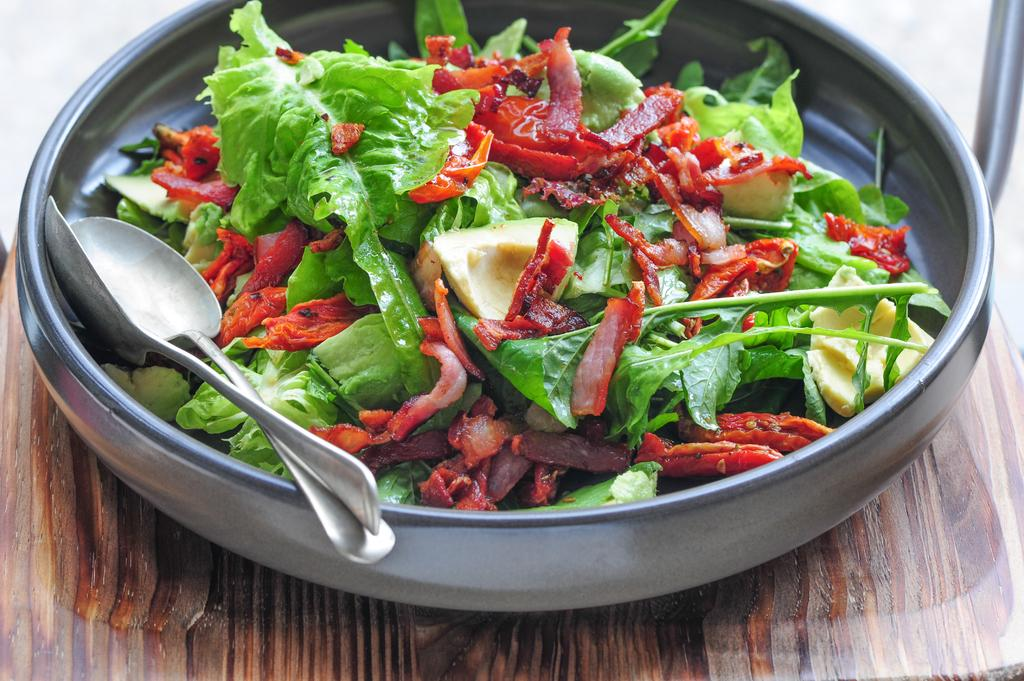What is the main object in the image? There is a wooden plank in the image. What is placed on the wooden plank? There is a dish with leafy vegetables on the wooden plank. How many spoons are in the dish? There are two spoons in the dish. What type of thunder can be heard in the background of the image? There is no thunder present in the image, as it is a still image of a wooden plank with a dish of leafy vegetables and spoons. 